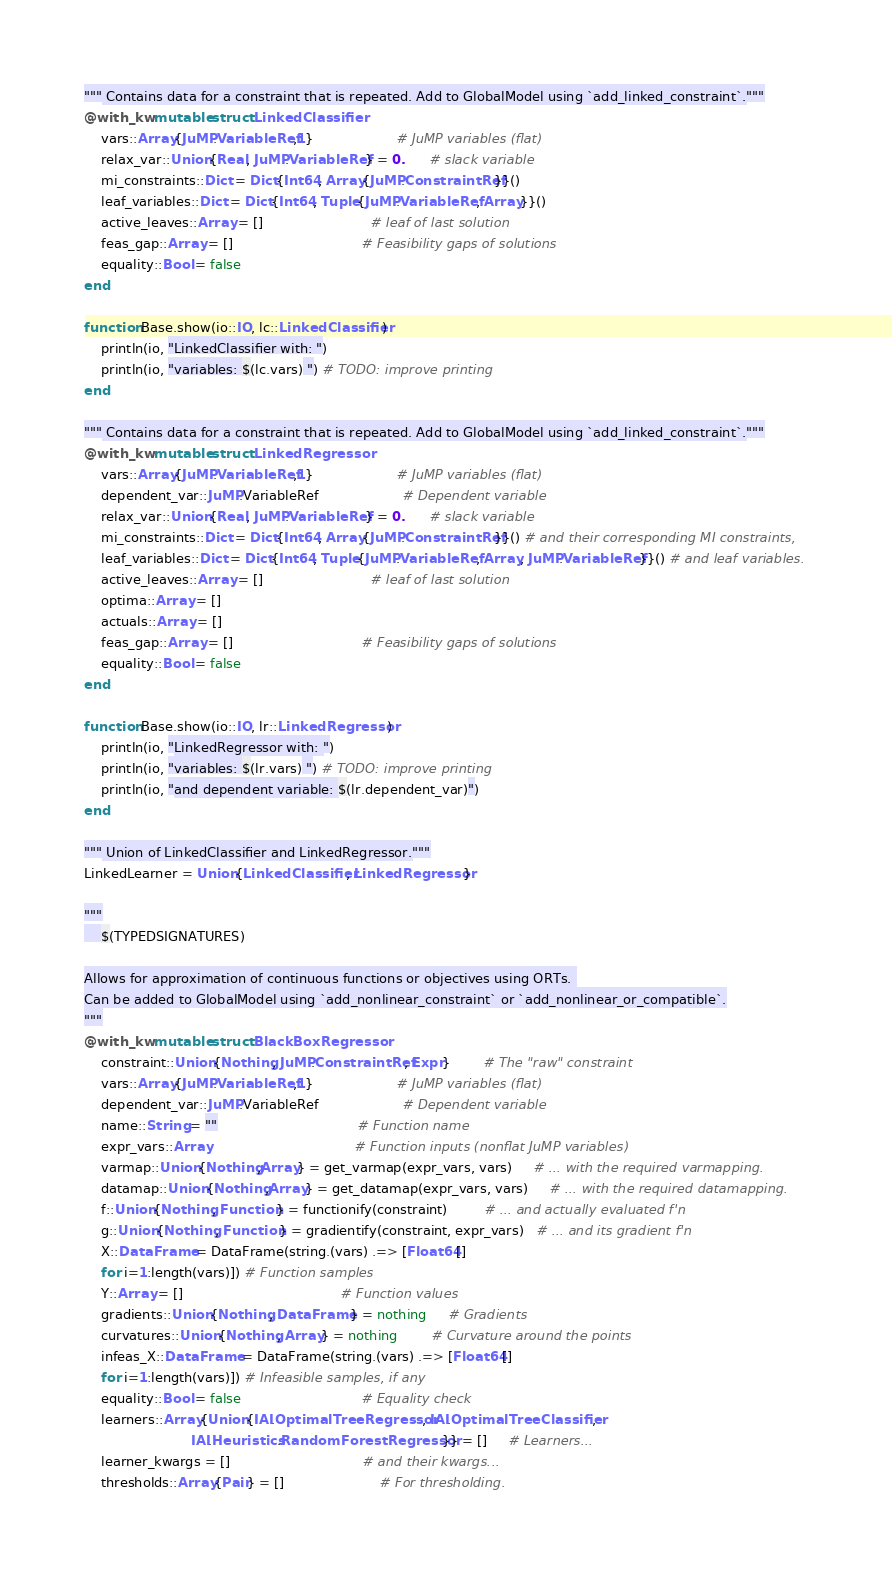<code> <loc_0><loc_0><loc_500><loc_500><_Julia_>""" Contains data for a constraint that is repeated. Add to GlobalModel using `add_linked_constraint`."""
@with_kw mutable struct LinkedClassifier
    vars::Array{JuMP.VariableRef,1}                    # JuMP variables (flat)
    relax_var::Union{Real, JuMP.VariableRef} = 0.      # slack variable        
    mi_constraints::Dict = Dict{Int64, Array{JuMP.ConstraintRef}}()
    leaf_variables::Dict = Dict{Int64, Tuple{JuMP.VariableRef, Array}}() 
    active_leaves::Array = []                          # leaf of last solution
    feas_gap::Array = []                               # Feasibility gaps of solutions   
    equality::Bool = false
end

function Base.show(io::IO, lc::LinkedClassifier)
    println(io, "LinkedClassifier with: ")
    println(io, "variables: $(lc.vars) ") # TODO: improve printing
end

""" Contains data for a constraint that is repeated. Add to GlobalModel using `add_linked_constraint`."""
@with_kw mutable struct LinkedRegressor
    vars::Array{JuMP.VariableRef,1}                    # JuMP variables (flat)
    dependent_var::JuMP.VariableRef                    # Dependent variable
    relax_var::Union{Real, JuMP.VariableRef} = 0.      # slack variable        
    mi_constraints::Dict = Dict{Int64, Array{JuMP.ConstraintRef}}() # and their corresponding MI constraints,
    leaf_variables::Dict = Dict{Int64, Tuple{JuMP.VariableRef, Array, JuMP.VariableRef}}() # and leaf variables. 
    active_leaves::Array = []                          # leaf of last solution    
    optima::Array = []
    actuals::Array = []
    feas_gap::Array = []                               # Feasibility gaps of solutions   
    equality::Bool = false
end

function Base.show(io::IO, lr::LinkedRegressor)
    println(io, "LinkedRegressor with: ")
    println(io, "variables: $(lr.vars) ") # TODO: improve printing
    println(io, "and dependent variable: $(lr.dependent_var)")
end

""" Union of LinkedClassifier and LinkedRegressor."""
LinkedLearner = Union{LinkedClassifier, LinkedRegressor}

"""
    $(TYPEDSIGNATURES)

Allows for approximation of continuous functions or objectives using ORTs. 
Can be added to GlobalModel using `add_nonlinear_constraint` or `add_nonlinear_or_compatible`.
"""
@with_kw mutable struct BlackBoxRegressor
    constraint::Union{Nothing, JuMP.ConstraintRef, Expr}        # The "raw" constraint
    vars::Array{JuMP.VariableRef,1}                    # JuMP variables (flat)
    dependent_var::JuMP.VariableRef                    # Dependent variable
    name::String = ""                                  # Function name
    expr_vars::Array                                   # Function inputs (nonflat JuMP variables)
    varmap::Union{Nothing,Array} = get_varmap(expr_vars, vars)     # ... with the required varmapping.
    datamap::Union{Nothing,Array} = get_datamap(expr_vars, vars)     # ... with the required datamapping.
    f::Union{Nothing, Function} = functionify(constraint)         # ... and actually evaluated f'n
    g::Union{Nothing, Function} = gradientify(constraint, expr_vars)   # ... and its gradient f'n
    X::DataFrame = DataFrame(string.(vars) .=> [Float64[] 
    for i=1:length(vars)]) # Function samples
    Y::Array = []                                      # Function values
    gradients::Union{Nothing, DataFrame} = nothing     # Gradients 
    curvatures::Union{Nothing, Array} = nothing        # Curvature around the points
    infeas_X::DataFrame = DataFrame(string.(vars) .=> [Float64[] 
    for i=1:length(vars)]) # Infeasible samples, if any
    equality::Bool = false                             # Equality check
    learners::Array{Union{IAI.OptimalTreeRegressor, IAI.OptimalTreeClassifier,
                          IAI.Heuristics.RandomForestRegressor}} = []     # Learners...
    learner_kwargs = []                                # and their kwargs... 
    thresholds::Array{Pair} = []                       # For thresholding. </code> 